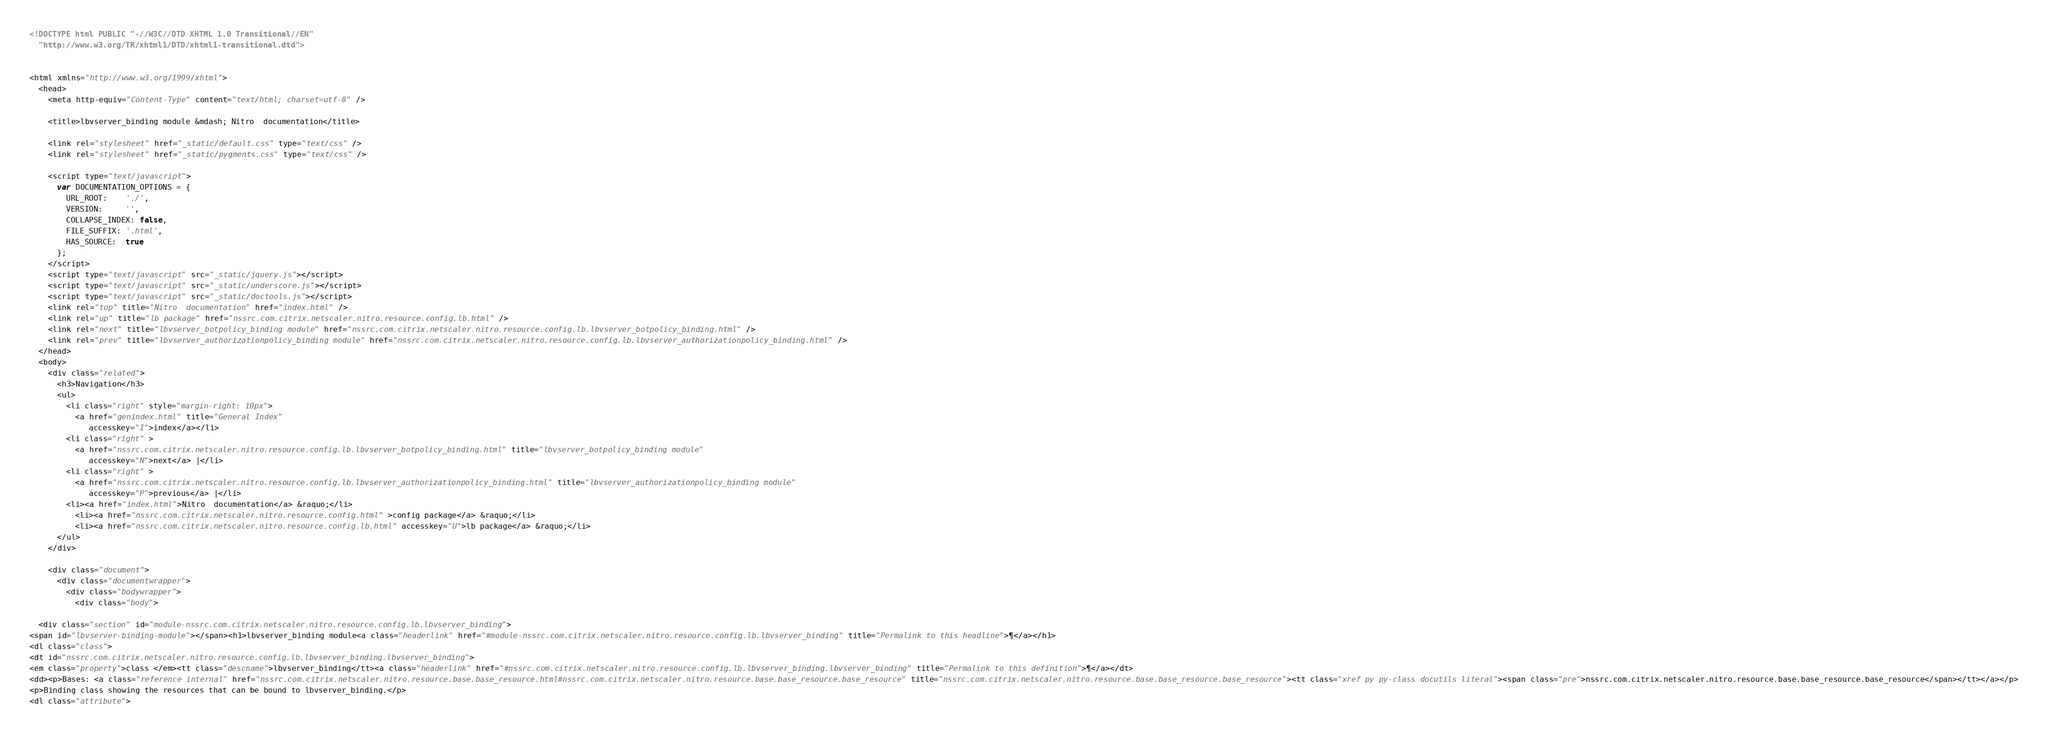<code> <loc_0><loc_0><loc_500><loc_500><_HTML_><!DOCTYPE html PUBLIC "-//W3C//DTD XHTML 1.0 Transitional//EN"
  "http://www.w3.org/TR/xhtml1/DTD/xhtml1-transitional.dtd">


<html xmlns="http://www.w3.org/1999/xhtml">
  <head>
    <meta http-equiv="Content-Type" content="text/html; charset=utf-8" />
    
    <title>lbvserver_binding module &mdash; Nitro  documentation</title>
    
    <link rel="stylesheet" href="_static/default.css" type="text/css" />
    <link rel="stylesheet" href="_static/pygments.css" type="text/css" />
    
    <script type="text/javascript">
      var DOCUMENTATION_OPTIONS = {
        URL_ROOT:    './',
        VERSION:     '',
        COLLAPSE_INDEX: false,
        FILE_SUFFIX: '.html',
        HAS_SOURCE:  true
      };
    </script>
    <script type="text/javascript" src="_static/jquery.js"></script>
    <script type="text/javascript" src="_static/underscore.js"></script>
    <script type="text/javascript" src="_static/doctools.js"></script>
    <link rel="top" title="Nitro  documentation" href="index.html" />
    <link rel="up" title="lb package" href="nssrc.com.citrix.netscaler.nitro.resource.config.lb.html" />
    <link rel="next" title="lbvserver_botpolicy_binding module" href="nssrc.com.citrix.netscaler.nitro.resource.config.lb.lbvserver_botpolicy_binding.html" />
    <link rel="prev" title="lbvserver_authorizationpolicy_binding module" href="nssrc.com.citrix.netscaler.nitro.resource.config.lb.lbvserver_authorizationpolicy_binding.html" /> 
  </head>
  <body>
    <div class="related">
      <h3>Navigation</h3>
      <ul>
        <li class="right" style="margin-right: 10px">
          <a href="genindex.html" title="General Index"
             accesskey="I">index</a></li>
        <li class="right" >
          <a href="nssrc.com.citrix.netscaler.nitro.resource.config.lb.lbvserver_botpolicy_binding.html" title="lbvserver_botpolicy_binding module"
             accesskey="N">next</a> |</li>
        <li class="right" >
          <a href="nssrc.com.citrix.netscaler.nitro.resource.config.lb.lbvserver_authorizationpolicy_binding.html" title="lbvserver_authorizationpolicy_binding module"
             accesskey="P">previous</a> |</li>
        <li><a href="index.html">Nitro  documentation</a> &raquo;</li>
          <li><a href="nssrc.com.citrix.netscaler.nitro.resource.config.html" >config package</a> &raquo;</li>
          <li><a href="nssrc.com.citrix.netscaler.nitro.resource.config.lb.html" accesskey="U">lb package</a> &raquo;</li> 
      </ul>
    </div>  

    <div class="document">
      <div class="documentwrapper">
        <div class="bodywrapper">
          <div class="body">
            
  <div class="section" id="module-nssrc.com.citrix.netscaler.nitro.resource.config.lb.lbvserver_binding">
<span id="lbvserver-binding-module"></span><h1>lbvserver_binding module<a class="headerlink" href="#module-nssrc.com.citrix.netscaler.nitro.resource.config.lb.lbvserver_binding" title="Permalink to this headline">¶</a></h1>
<dl class="class">
<dt id="nssrc.com.citrix.netscaler.nitro.resource.config.lb.lbvserver_binding.lbvserver_binding">
<em class="property">class </em><tt class="descname">lbvserver_binding</tt><a class="headerlink" href="#nssrc.com.citrix.netscaler.nitro.resource.config.lb.lbvserver_binding.lbvserver_binding" title="Permalink to this definition">¶</a></dt>
<dd><p>Bases: <a class="reference internal" href="nssrc.com.citrix.netscaler.nitro.resource.base.base_resource.html#nssrc.com.citrix.netscaler.nitro.resource.base.base_resource.base_resource" title="nssrc.com.citrix.netscaler.nitro.resource.base.base_resource.base_resource"><tt class="xref py py-class docutils literal"><span class="pre">nssrc.com.citrix.netscaler.nitro.resource.base.base_resource.base_resource</span></tt></a></p>
<p>Binding class showing the resources that can be bound to lbvserver_binding.</p>
<dl class="attribute"></code> 